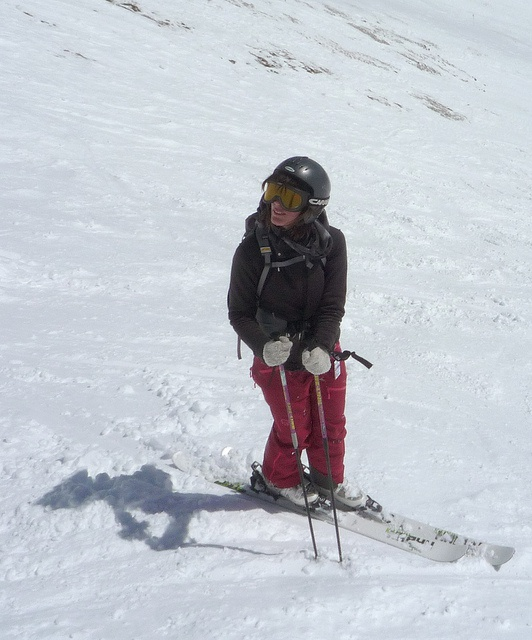Describe the objects in this image and their specific colors. I can see people in lightgray, black, maroon, gray, and darkgray tones, skis in lightgray, darkgray, and gray tones, and backpack in lightgray, black, and gray tones in this image. 